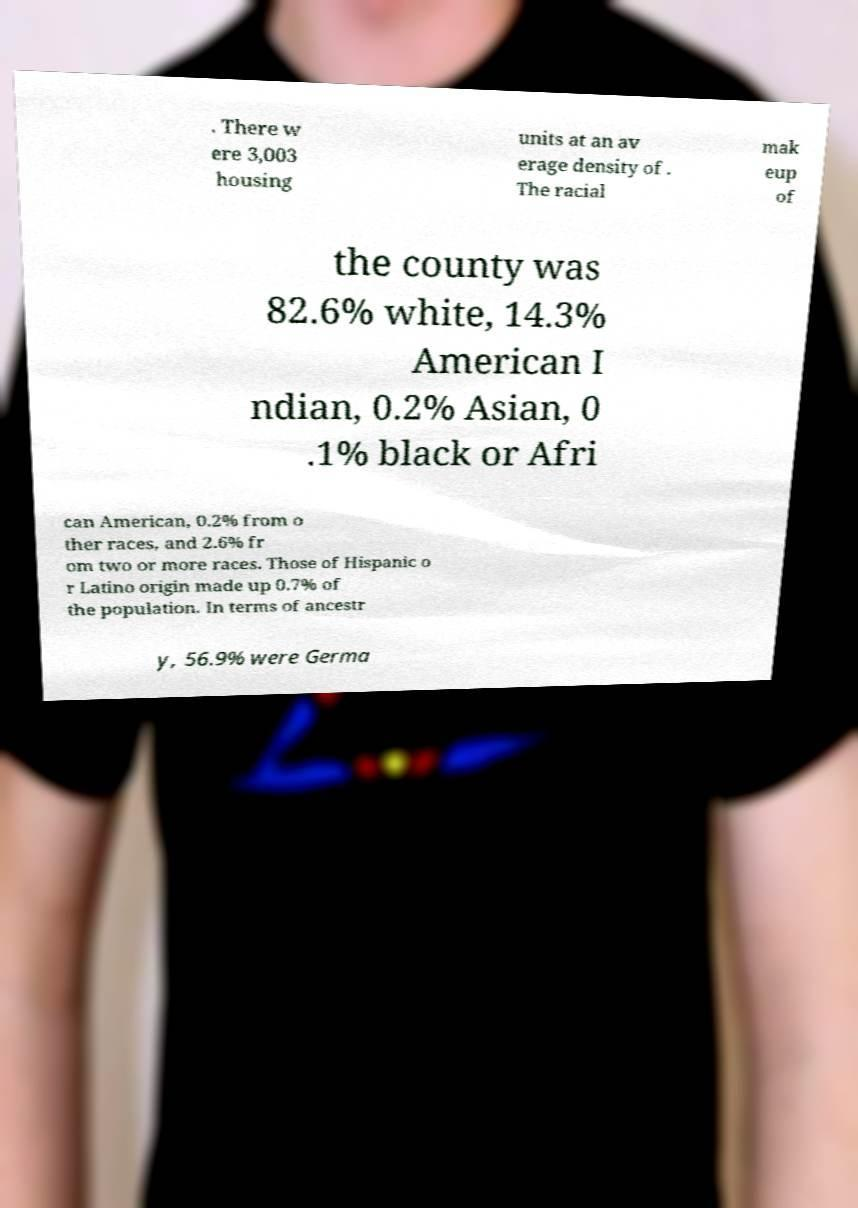There's text embedded in this image that I need extracted. Can you transcribe it verbatim? . There w ere 3,003 housing units at an av erage density of . The racial mak eup of the county was 82.6% white, 14.3% American I ndian, 0.2% Asian, 0 .1% black or Afri can American, 0.2% from o ther races, and 2.6% fr om two or more races. Those of Hispanic o r Latino origin made up 0.7% of the population. In terms of ancestr y, 56.9% were Germa 